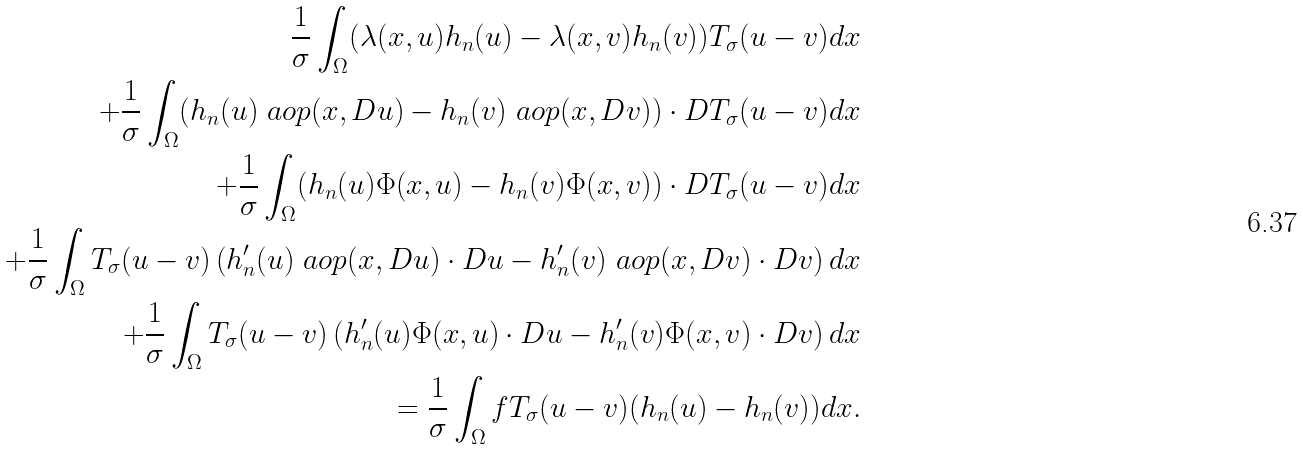<formula> <loc_0><loc_0><loc_500><loc_500>\frac { 1 } { \sigma } \int _ { \Omega } ( \lambda ( x , u ) h _ { n } ( u ) - \lambda ( x , v ) h _ { n } ( v ) ) T _ { \sigma } ( u - v ) d x \\ + \frac { 1 } { \sigma } \int _ { \Omega } ( h _ { n } ( u ) \ a o p ( x , D u ) - h _ { n } ( v ) \ a o p ( x , D v ) ) \cdot D T _ { \sigma } ( u - v ) d x \\ + \frac { 1 } { \sigma } \int _ { \Omega } ( h _ { n } ( u ) \Phi ( x , u ) - h _ { n } ( v ) \Phi ( x , v ) ) \cdot D T _ { \sigma } ( u - v ) d x \\ + \frac { 1 } { \sigma } \int _ { \Omega } T _ { \sigma } ( u - v ) \left ( h _ { n } ^ { \prime } ( u ) \ a o p ( x , D u ) \cdot D u - h _ { n } ^ { \prime } ( v ) \ a o p ( x , D v ) \cdot D v \right ) d x \\ + \frac { 1 } { \sigma } \int _ { \Omega } T _ { \sigma } ( u - v ) \left ( h _ { n } ^ { \prime } ( u ) \Phi ( x , u ) \cdot D u - h _ { n } ^ { \prime } ( v ) \Phi ( x , v ) \cdot D v \right ) d x \\ = \frac { 1 } { \sigma } \int _ { \Omega } f T _ { \sigma } ( u - v ) ( h _ { n } ( u ) - h _ { n } ( v ) ) d x .</formula> 